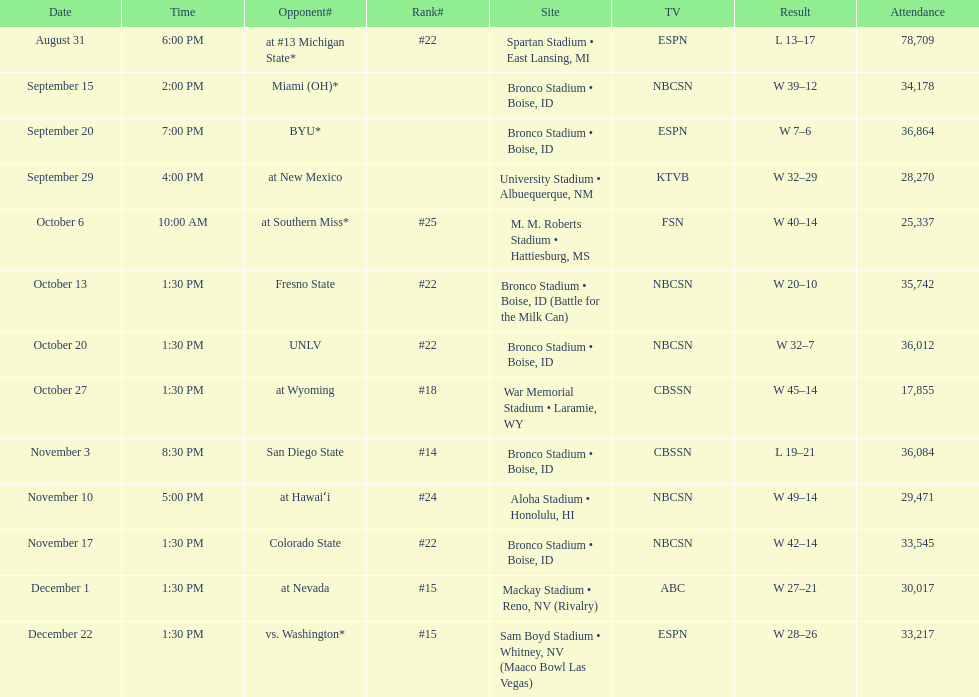Amount of points achieved by miami (oh) versus the broncos. 12. 